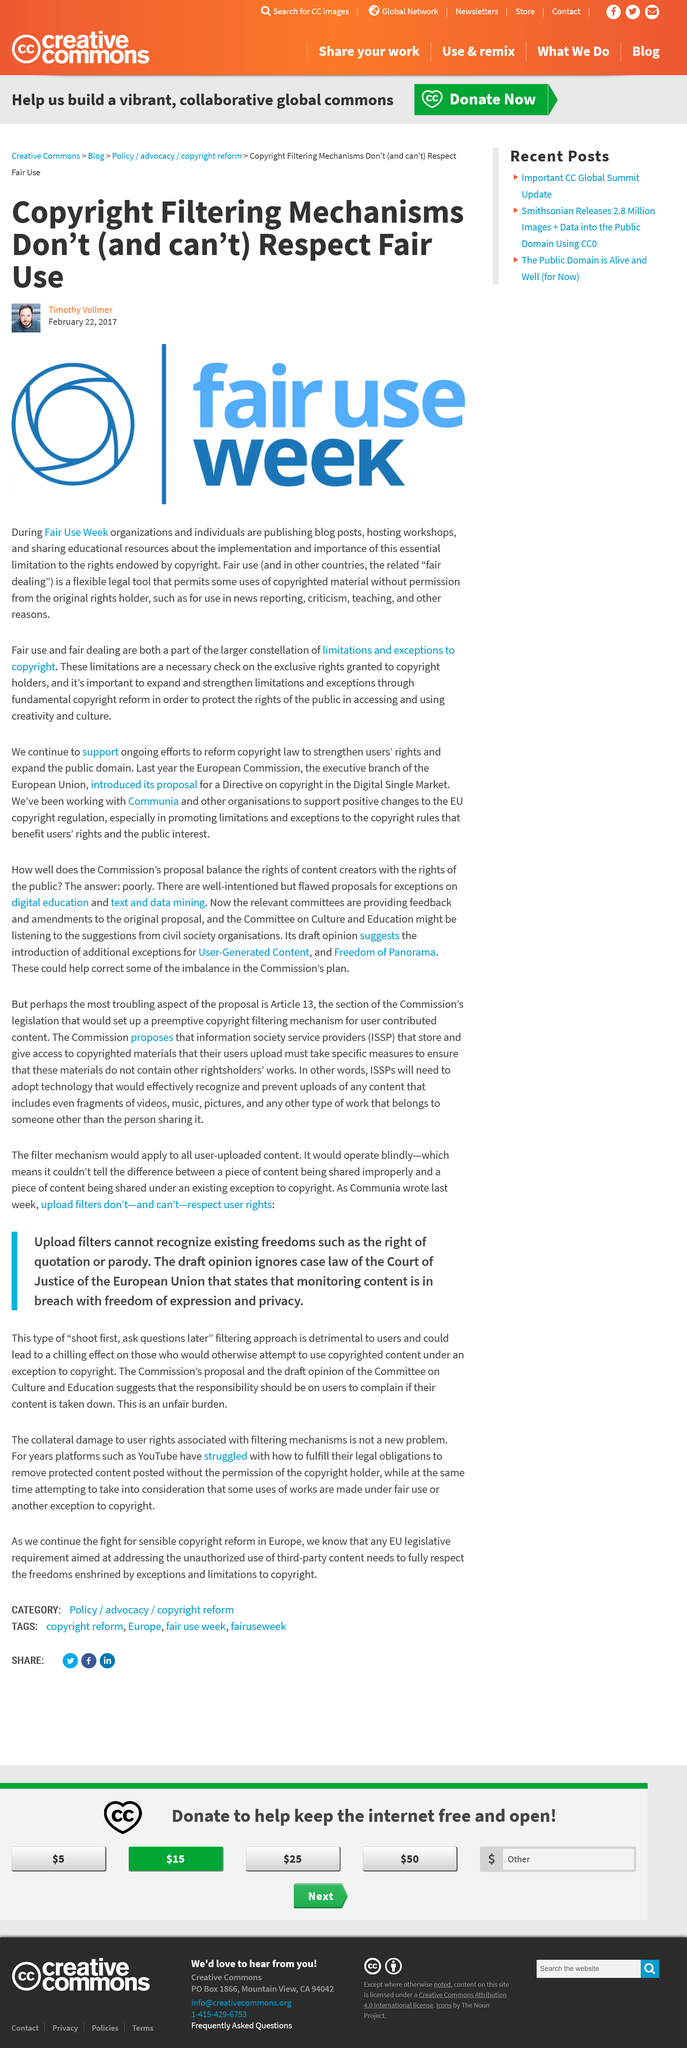Highlight a few significant elements in this photo. Fair use is a legal tool that is utilized in news reporting and similar contexts and is designed to be flexible in order to promote the free flow of information. The week in which people highlight the legal tool is Fair Use Week, and during this week, the legal tool is being showcased. Fair use is known in other countries as fair dealing. 